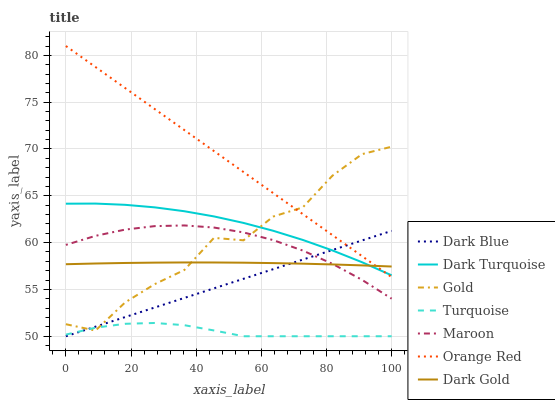Does Turquoise have the minimum area under the curve?
Answer yes or no. Yes. Does Orange Red have the maximum area under the curve?
Answer yes or no. Yes. Does Gold have the minimum area under the curve?
Answer yes or no. No. Does Gold have the maximum area under the curve?
Answer yes or no. No. Is Dark Blue the smoothest?
Answer yes or no. Yes. Is Gold the roughest?
Answer yes or no. Yes. Is Dark Gold the smoothest?
Answer yes or no. No. Is Dark Gold the roughest?
Answer yes or no. No. Does Turquoise have the lowest value?
Answer yes or no. Yes. Does Gold have the lowest value?
Answer yes or no. No. Does Orange Red have the highest value?
Answer yes or no. Yes. Does Gold have the highest value?
Answer yes or no. No. Is Maroon less than Orange Red?
Answer yes or no. Yes. Is Dark Gold greater than Turquoise?
Answer yes or no. Yes. Does Dark Blue intersect Orange Red?
Answer yes or no. Yes. Is Dark Blue less than Orange Red?
Answer yes or no. No. Is Dark Blue greater than Orange Red?
Answer yes or no. No. Does Maroon intersect Orange Red?
Answer yes or no. No. 